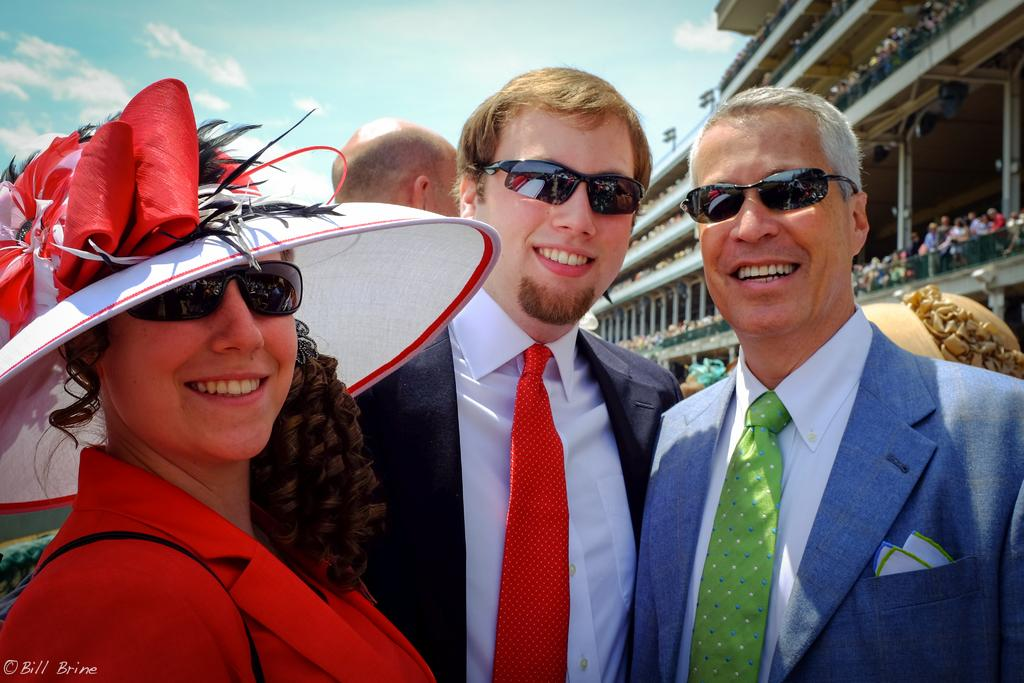What is happening in the image involving a group of people? The people in the image are standing and smiling together. Can you describe any specific details about the people in the group? Yes, there is a lady wearing a hat in the group. What can be seen in the background of the image? There is a stadium visible in the background of the image. How many people are present in the stadium? The stadium has many people. Can you tell me what type of owl is sitting on the lady's hat in the image? There is no owl present on the lady's hat in the image. What is the nature of the love between the people in the image? The image does not provide information about the nature of love between the people; it only shows them standing and smiling together. 